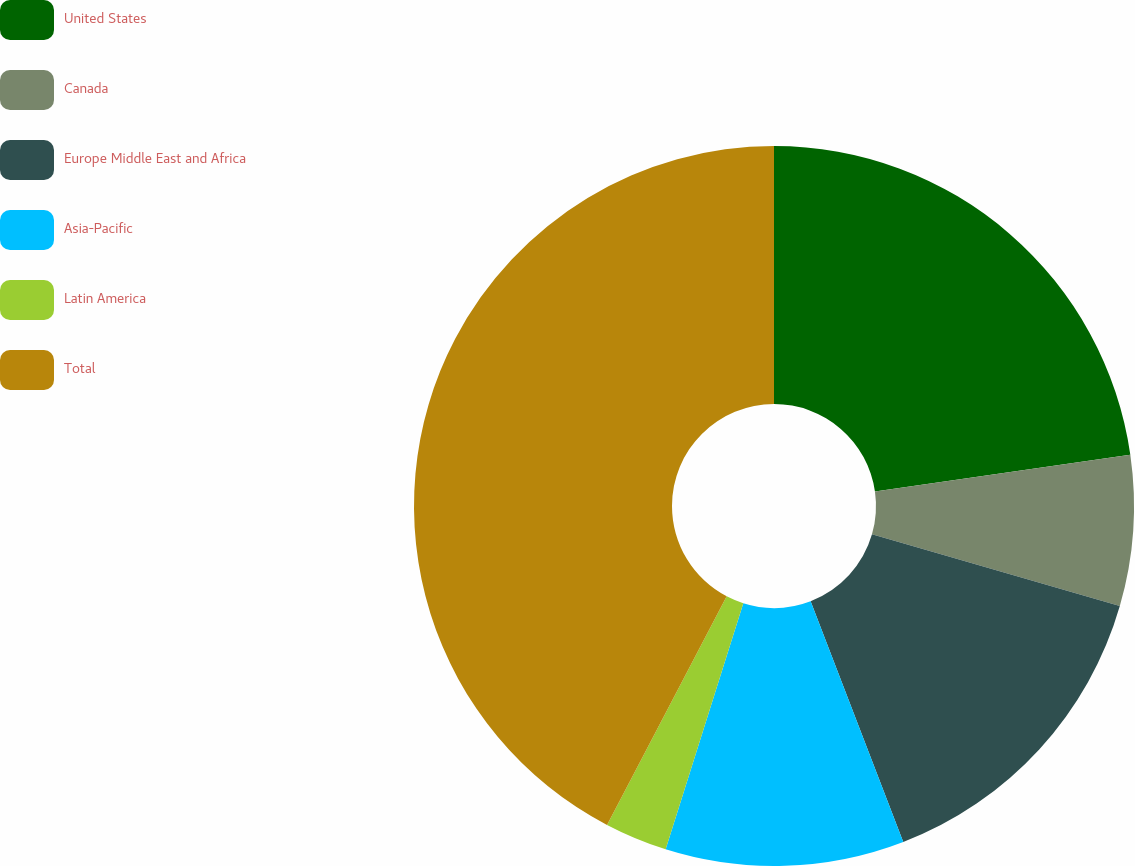Convert chart. <chart><loc_0><loc_0><loc_500><loc_500><pie_chart><fcel>United States<fcel>Canada<fcel>Europe Middle East and Africa<fcel>Asia-Pacific<fcel>Latin America<fcel>Total<nl><fcel>22.72%<fcel>6.76%<fcel>14.67%<fcel>10.71%<fcel>2.81%<fcel>42.32%<nl></chart> 